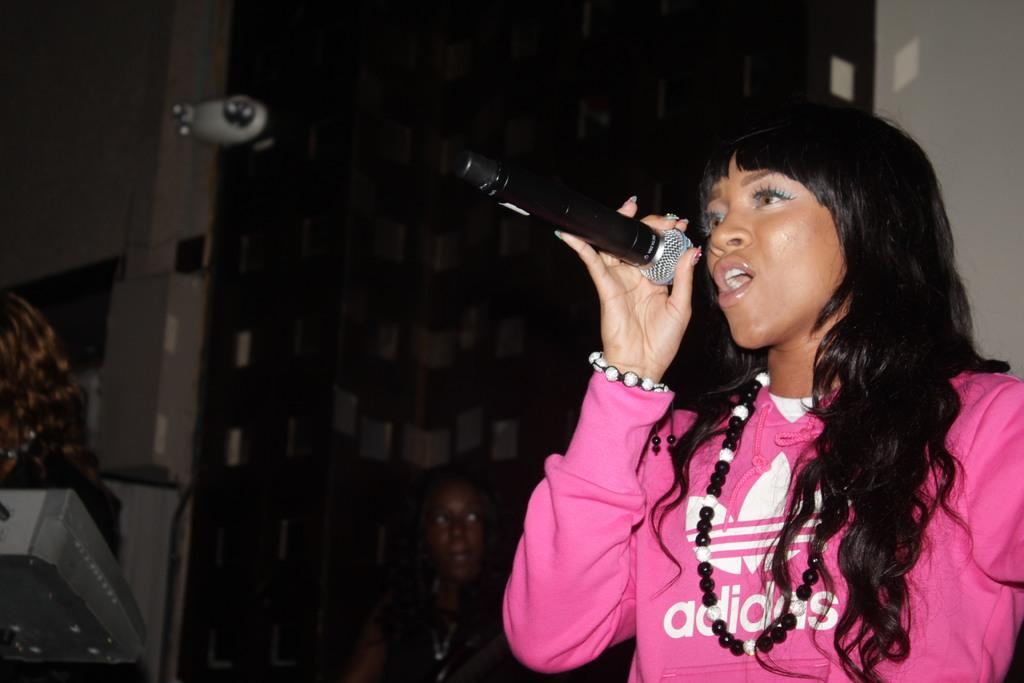What is the woman in the image doing? The woman is standing and singing in the image. What is the woman holding in her hand? The woman is holding a mic in her hand. What is the woman wearing in the image? The woman is wearing a pink dress. What can be seen in the background of the image? There is a wall in the background of the image, and another woman sitting. What type of bomb is the woman holding in the image? There is no bomb present in the image; the woman is holding a mic. What kind of meal is being prepared in the background of the image? There is no meal preparation visible in the image; only a wall and another woman sitting are present in the background. 